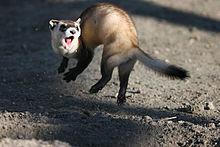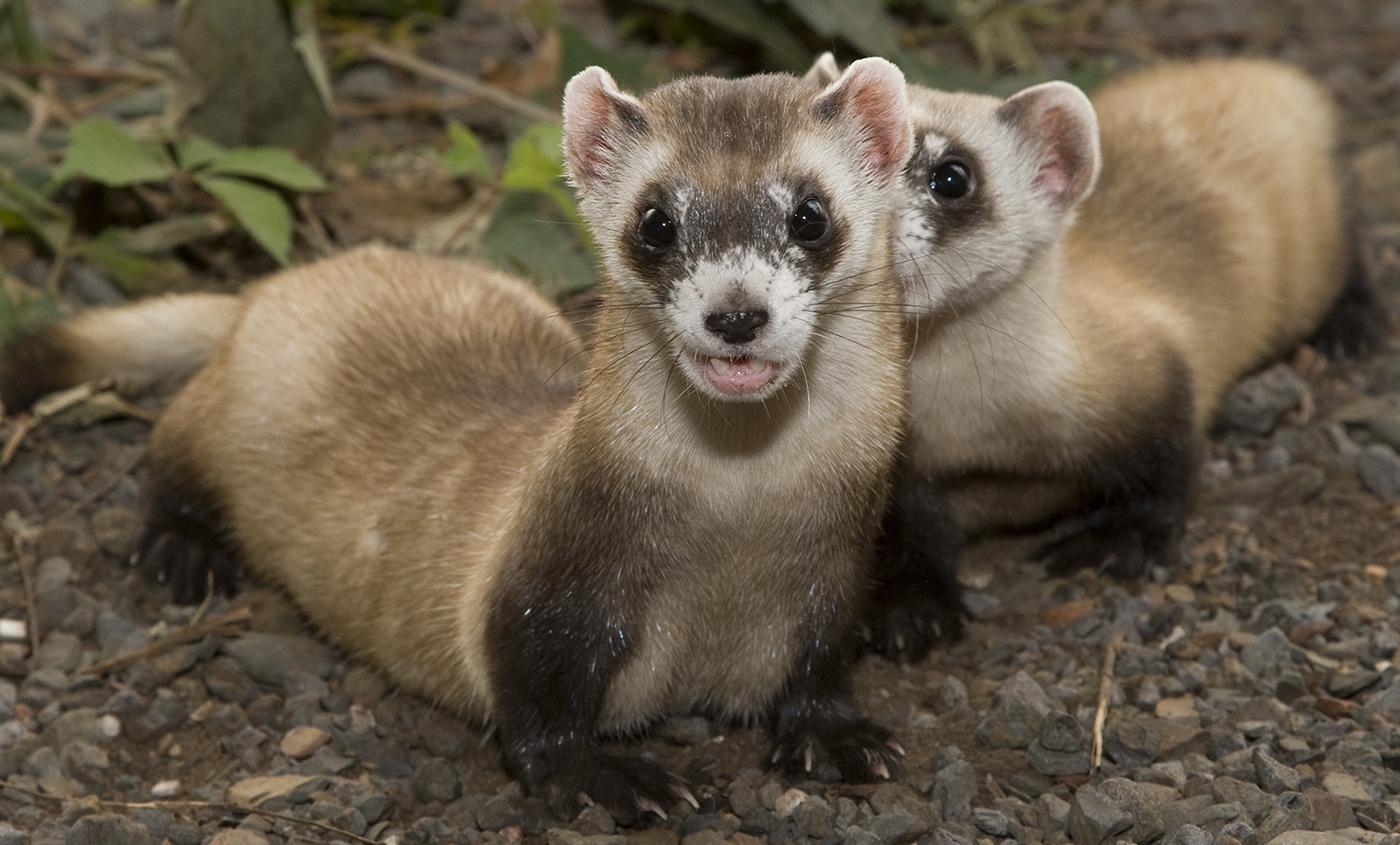The first image is the image on the left, the second image is the image on the right. Evaluate the accuracy of this statement regarding the images: "There are no more than two ferrets.". Is it true? Answer yes or no. No. The first image is the image on the left, the second image is the image on the right. Considering the images on both sides, is "At least one of the animals is partly in a hole." valid? Answer yes or no. No. 